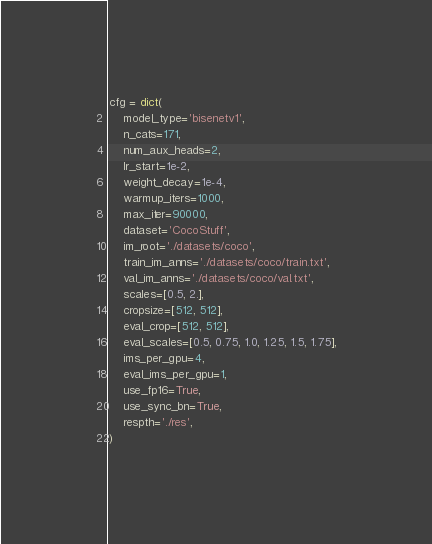<code> <loc_0><loc_0><loc_500><loc_500><_Python_>
cfg = dict(
    model_type='bisenetv1',
    n_cats=171,
    num_aux_heads=2,
    lr_start=1e-2,
    weight_decay=1e-4,
    warmup_iters=1000,
    max_iter=90000,
    dataset='CocoStuff',
    im_root='./datasets/coco',
    train_im_anns='./datasets/coco/train.txt',
    val_im_anns='./datasets/coco/val.txt',
    scales=[0.5, 2.],
    cropsize=[512, 512],
    eval_crop=[512, 512],
    eval_scales=[0.5, 0.75, 1.0, 1.25, 1.5, 1.75],
    ims_per_gpu=4,
    eval_ims_per_gpu=1,
    use_fp16=True,
    use_sync_bn=True,
    respth='./res',
)
</code> 